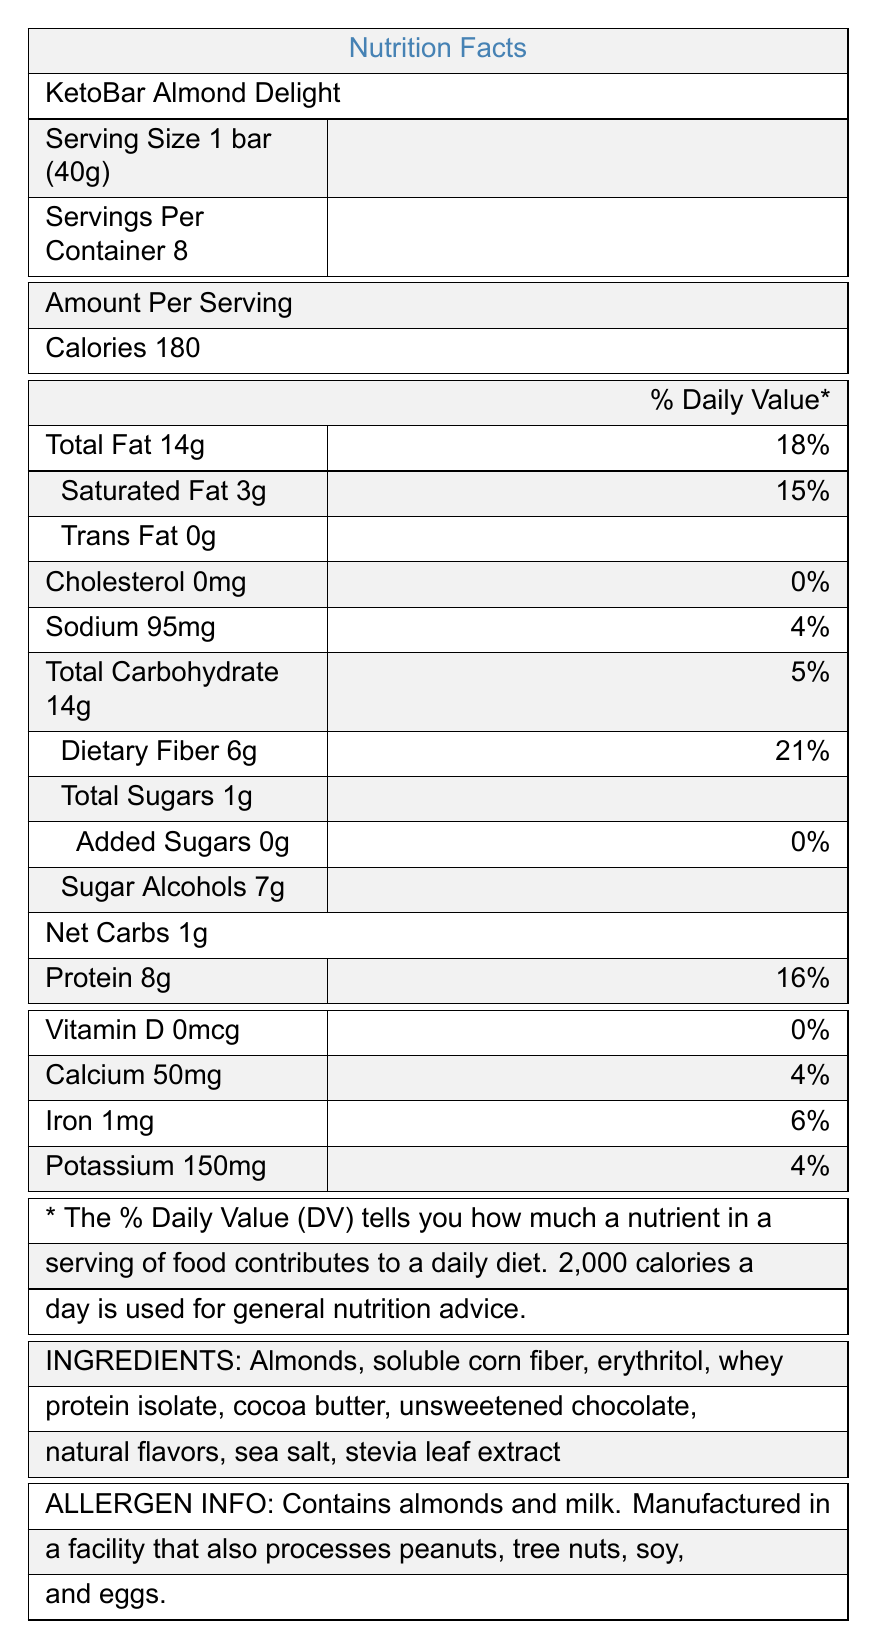what is the serving size of KetoBar Almond Delight? The serving size is clearly mentioned at the top of the Nutrition Facts Label.
Answer: 1 bar (40g) how many servings are there in one container? The document states "Servings Per Container: 8" right below the Serving Size information.
Answer: 8 how many grams of protein are there per serving? Under "Amount Per Serving," the protein content is listed as 8g.
Answer: 8g what is the net carbs content per serving? The document specifically provides a "Net Carbs" value of 1g per serving.
Answer: 1g how much dietary fiber is in one serving? Dietary fiber is listed as 6g under "Total Carbohydrate."
Answer: 6g are there any added sugars in the product? The label specifies "Added Sugars 0g" with a 0% daily value.
Answer: No how much calcium is in one serving of KetoBar Almond Delight? Under the vitamin and mineral section, calcium is listed as 50mg.
Answer: 50mg what is the calorie count per serving of this snack bar? A. 100 B. 150 C. 180 D. 200 The calories are prominently displayed in large font as 180 per serving.
Answer: C does the product contain any cholesterol? Cholesterol is marked as 0mg, and also highlighted with a 0% daily value.
Answer: No is this product suitable for someone who is lactose intolerant? The allergen information reveals that the product contains milk, making it unsuitable for individuals with lactose intolerance.
Answer: No how many grams of sugar alcohols are there in one bar? It's mentioned directly under the "Total Carbohydrate" section as "Sugar Alcohols 7g."
Answer: 7g can we determine the manufacturing facility's safety practices from the document? The document only provides allergen information and mentions the facility processes other allergens; it does not detail the safety practices.
Answer: Cannot be determined which vitamins and minerals are listed without providing any percentage of daily value? The document lists Vitamin D with 0mcg and 0% daily value.
Answer: Vitamin D summarize the main idea of this document. The summary should capture the essence of the nutrition facts, including serving size, key nutritional values, focus on low net carbs, and allergen and ingredient specifics.
Answer: This document provides the detailed nutrition facts for KetoBar Almond Delight, focusing on its serving size, calories, macronutrients, fiber, vitamins, and minerals. It highlights the low net carbs and sugar alcohol content, suitable for a keto diet, and includes allergen and ingredient information. 